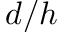Convert formula to latex. <formula><loc_0><loc_0><loc_500><loc_500>d / h</formula> 